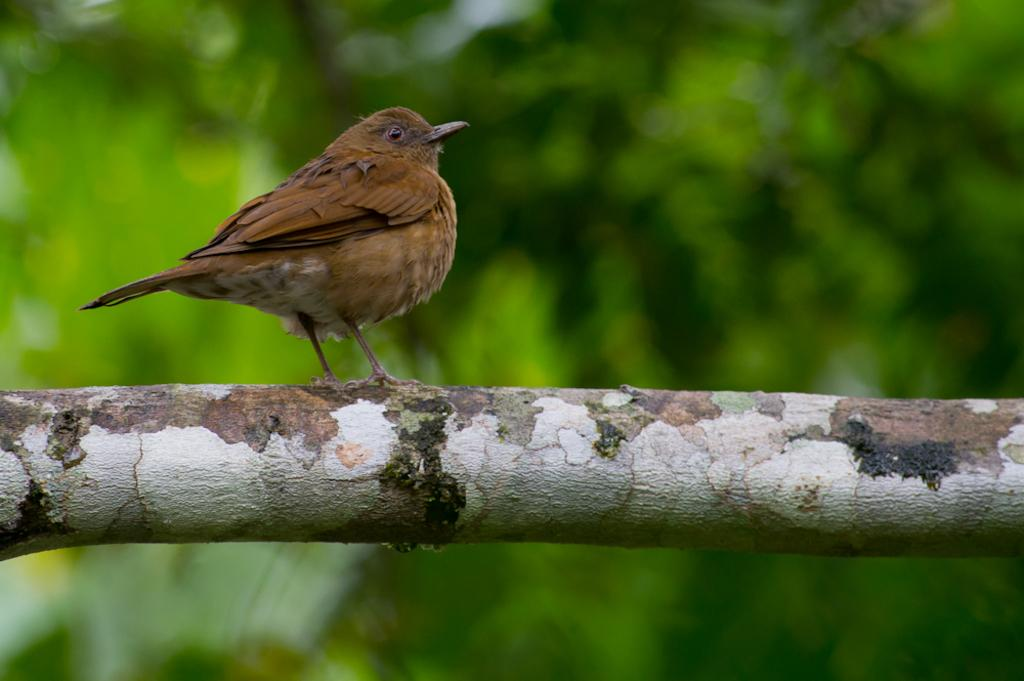What type of animal can be seen in the image? There is a bird in the image. Where is the bird located? The bird is on a wooden surface. Can you describe the background of the image? The background of the image is blurred and green. What type of education does the bird have in the image? There is no indication of the bird's education in the image. How does the heat affect the bird in the image? The image does not provide any information about the temperature or heat, so we cannot determine its effect on the bird. 